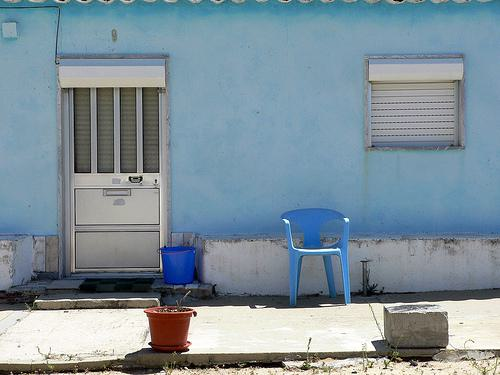How many unicorns would there be in the image if three additional unicorns were added in the scene? Since there are no unicorns visible in the image initially, adding three unicorns would bring the total number of unicorns in the scene to three. 